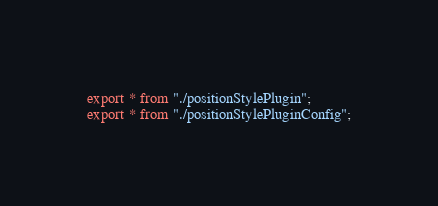<code> <loc_0><loc_0><loc_500><loc_500><_TypeScript_>export * from "./positionStylePlugin";
export * from "./positionStylePluginConfig";</code> 